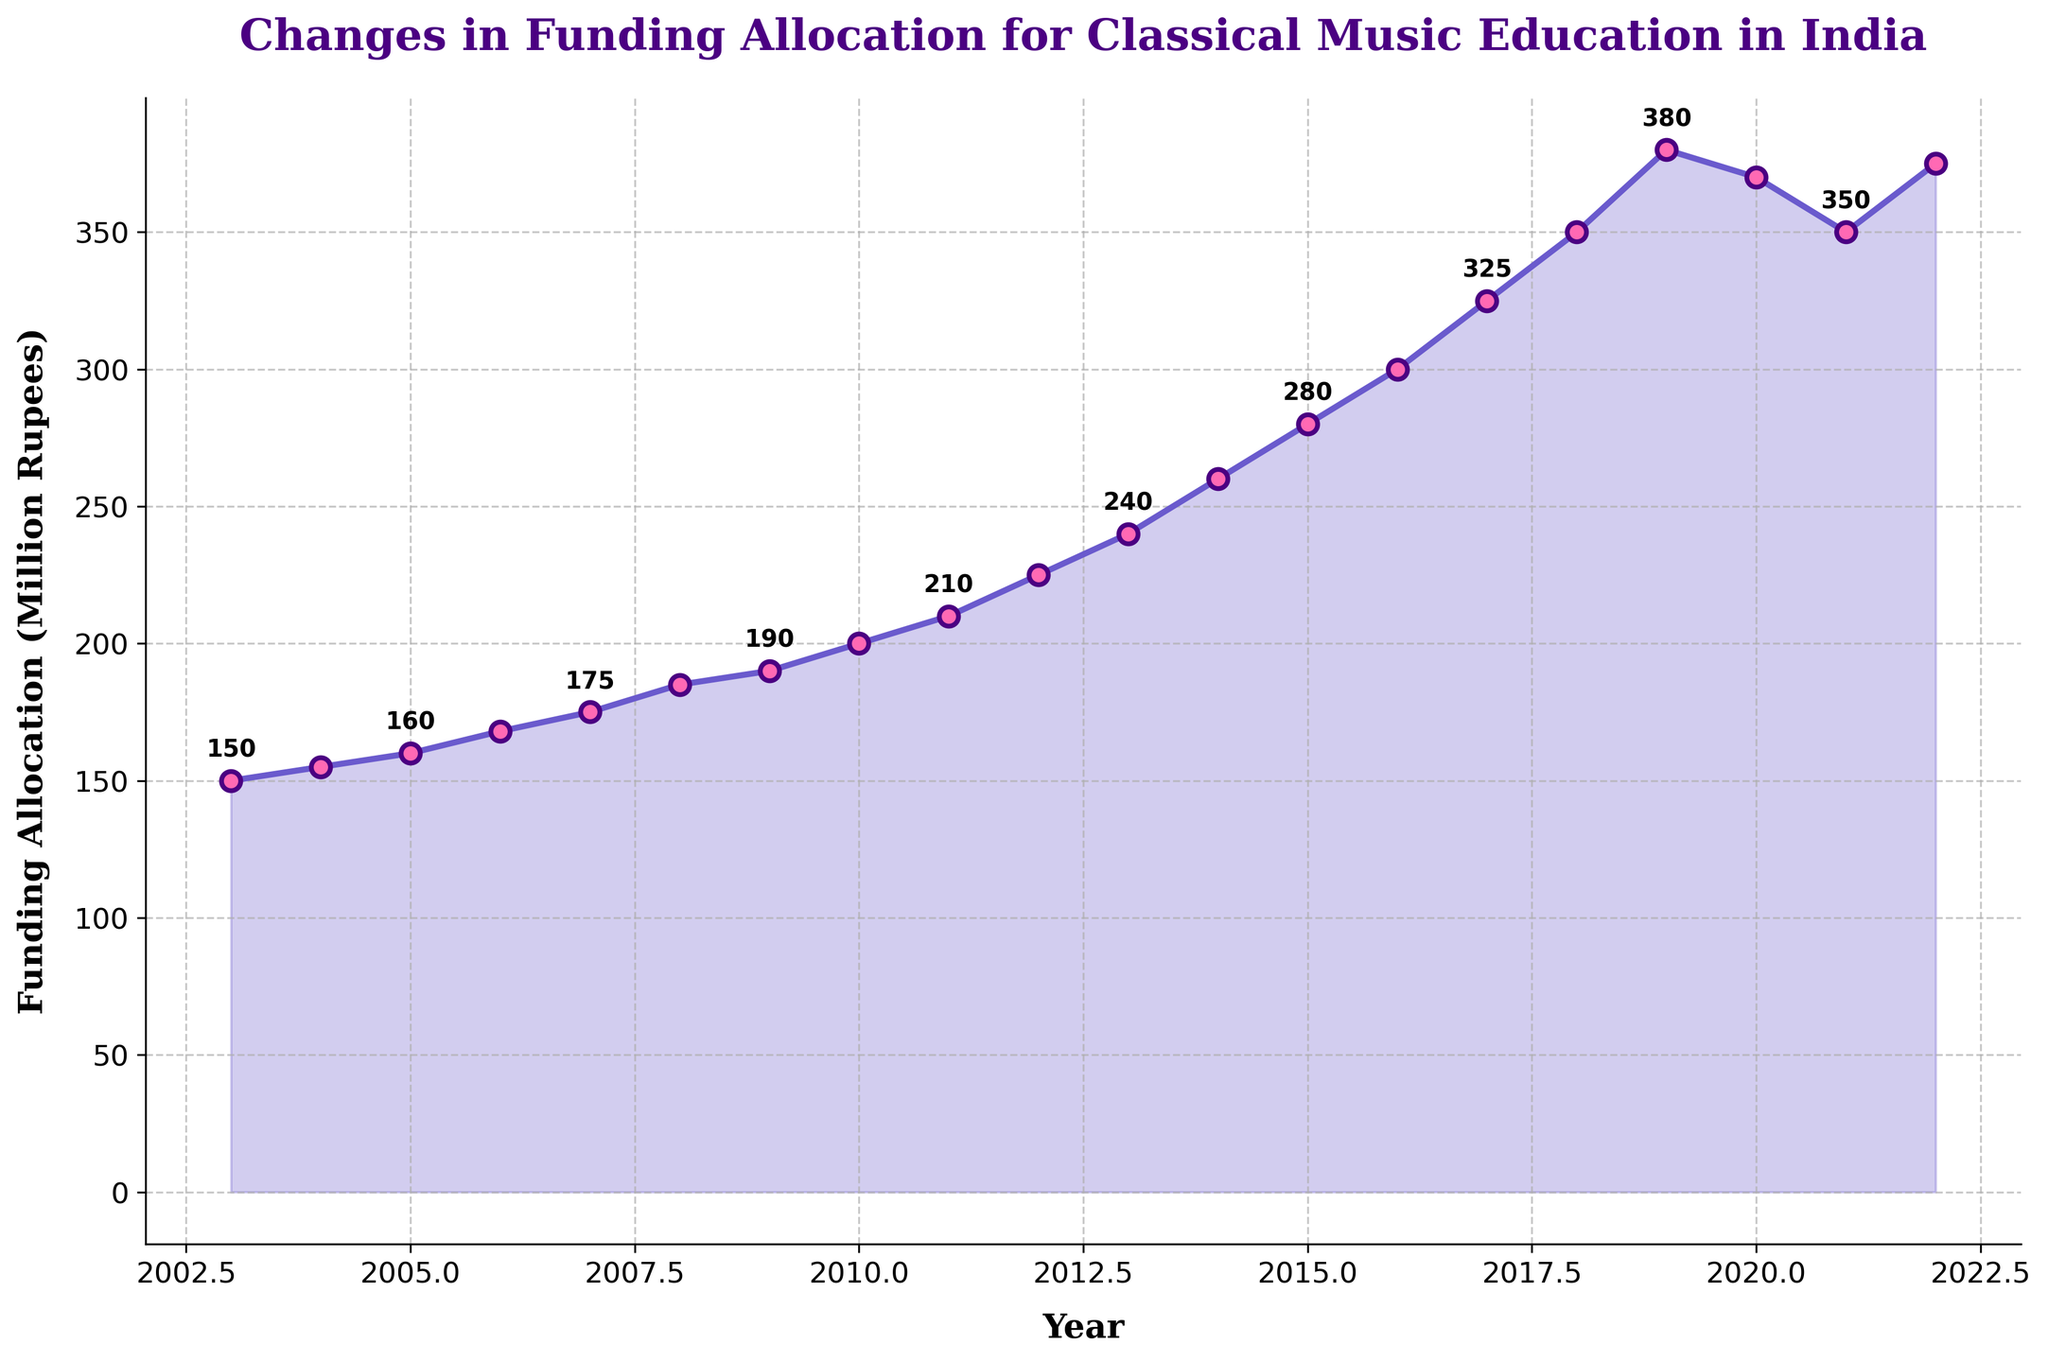Which year had the highest funding allocation? From the figure, look for the year on the x-axis where the funding allocation peaked. The graph shows the highest point at 2019, with a funding allocation of 380 Million Rupees.
Answer: 2019 What is the difference in funding allocation between 2019 and 2020? First, find the funding allocation for 2019, which is 380 million rupees. Then find the funding for 2020, which is 370 million rupees. Subtract the 2020 value from the 2019 value: 380 - 370 = 10 million rupees.
Answer: 10 million rupees By how much did the funding allocation increase from 2003 to 2022? Look at the funding value for 2003, which is 150 million rupees, and for 2022, which is 375 million rupees. Subtract the 2003 value from the 2022 value: 375 - 150 = 225 million rupees.
Answer: 225 million rupees Between which two consecutive years was the highest increase in funding observed? Examine the figure and look at the differences between consecutive years. The largest increase appears between 2018 and 2019, where the funding went from 350 million rupees to 380 million rupees, an increase of 30 million rupees.
Answer: 2018 and 2019 Which two-year period saw a decline in funding allocation? Identify the years where the funding allocation decreases. From the figure, the decline is seen between 2019 and 2020, and another decline from 2020 to 2021.
Answer: 2019 to 2020 and 2020 to 2021 What is the average funding allocation over the first 5 years (2003-2007)? Identify the funding values for 2003 to 2007: 150, 155, 160, 168, 175. Sum these values and then divide by the number of years: (150 + 155 + 160 + 168 + 175) / 5 = 161.6 million rupees.
Answer: 161.6 million rupees How does the funding allocation in 2022 compare to 2020? Look at the funding values for 2020 and 2022. The 2020 value is 370 million rupees, and the 2022 value is 375 million rupees. The funding in 2022 is 5 million rupees higher than in 2020.
Answer: Higher by 5 million rupees What trend can be observed between 2005 and 2015? The graph indicates a consistent upward trend in funding from 2005 (160 million rupees) to 2015 (280 million rupees), with no declines.
Answer: Upward trend What was the lowest funding allocation over the entire period? By observing the graph, the lowest point occurs in 2003 with 150 million rupees.
Answer: 150 million rupees 